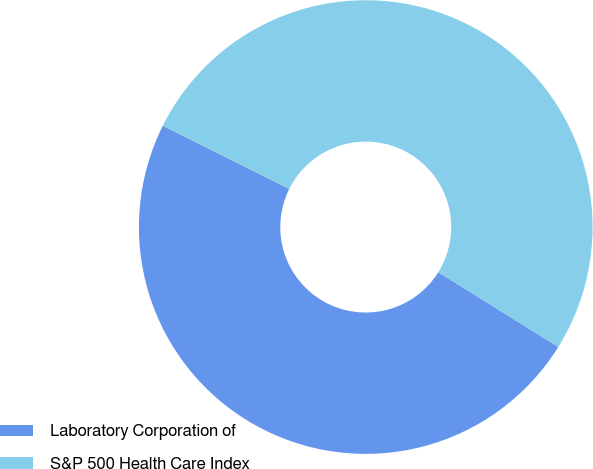<chart> <loc_0><loc_0><loc_500><loc_500><pie_chart><fcel>Laboratory Corporation of<fcel>S&P 500 Health Care Index<nl><fcel>48.51%<fcel>51.49%<nl></chart> 